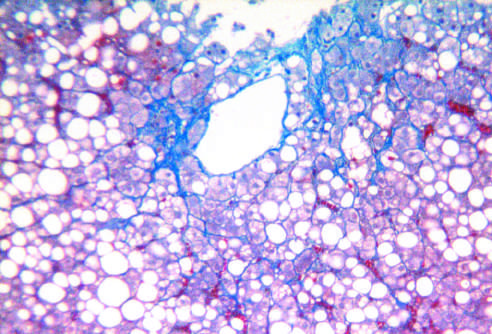what is fatty liver disease associated with?
Answer the question using a single word or phrase. Chronic alcohol use 